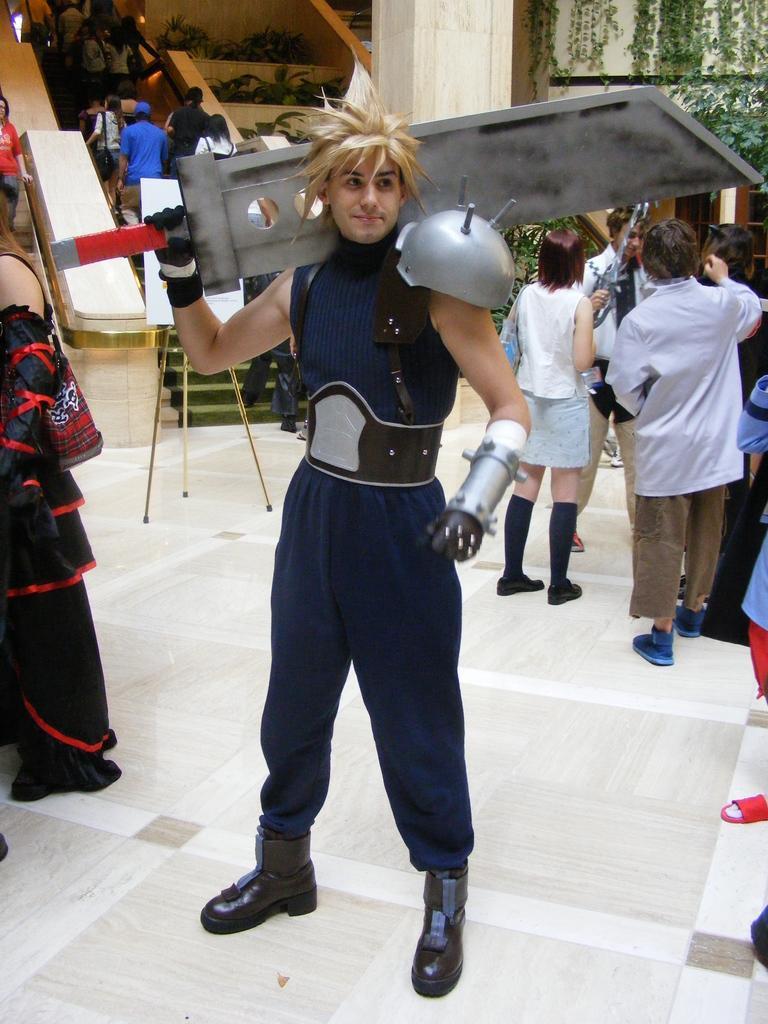How would you summarize this image in a sentence or two? In the picture I can see a group of people are standing on the floor among them the man in the front is holding an object in the hand. In the background I can see a board, plants and some other objects. 